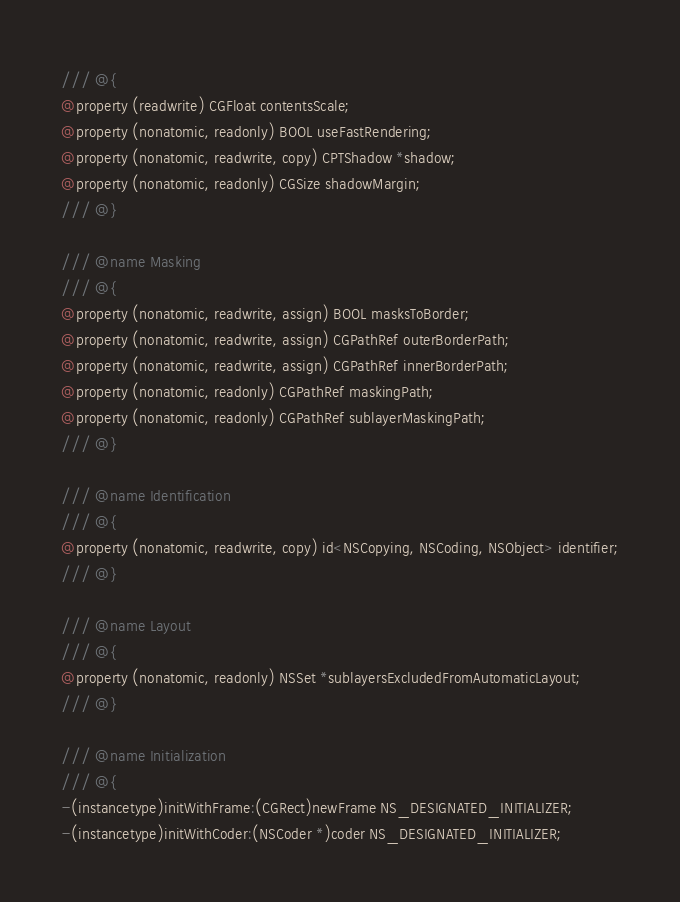<code> <loc_0><loc_0><loc_500><loc_500><_C_>/// @{
@property (readwrite) CGFloat contentsScale;
@property (nonatomic, readonly) BOOL useFastRendering;
@property (nonatomic, readwrite, copy) CPTShadow *shadow;
@property (nonatomic, readonly) CGSize shadowMargin;
/// @}

/// @name Masking
/// @{
@property (nonatomic, readwrite, assign) BOOL masksToBorder;
@property (nonatomic, readwrite, assign) CGPathRef outerBorderPath;
@property (nonatomic, readwrite, assign) CGPathRef innerBorderPath;
@property (nonatomic, readonly) CGPathRef maskingPath;
@property (nonatomic, readonly) CGPathRef sublayerMaskingPath;
/// @}

/// @name Identification
/// @{
@property (nonatomic, readwrite, copy) id<NSCopying, NSCoding, NSObject> identifier;
/// @}

/// @name Layout
/// @{
@property (nonatomic, readonly) NSSet *sublayersExcludedFromAutomaticLayout;
/// @}

/// @name Initialization
/// @{
-(instancetype)initWithFrame:(CGRect)newFrame NS_DESIGNATED_INITIALIZER;
-(instancetype)initWithCoder:(NSCoder *)coder NS_DESIGNATED_INITIALIZER;</code> 